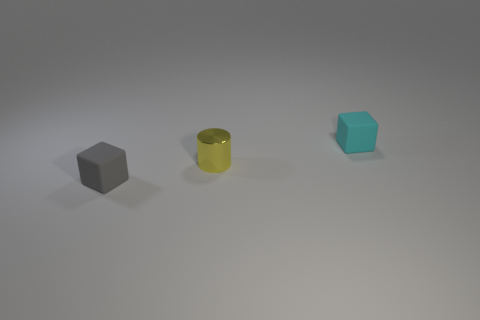There is a matte thing that is in front of the matte object behind the rubber thing in front of the tiny metal cylinder; what size is it?
Offer a very short reply. Small. There is a gray thing; is its shape the same as the yellow shiny object that is in front of the cyan block?
Ensure brevity in your answer.  No. How many things are left of the small cyan cube and behind the metal cylinder?
Keep it short and to the point. 0. How many purple things are either matte cubes or large metallic blocks?
Give a very brief answer. 0. There is a tiny rubber object that is behind the gray cube; is it the same color as the tiny cylinder behind the small gray matte thing?
Your response must be concise. No. What color is the rubber cube that is to the left of the matte block that is on the right side of the rubber cube that is in front of the tiny cyan rubber block?
Make the answer very short. Gray. There is a block that is in front of the tiny cyan matte thing; is there a gray rubber block that is right of it?
Your answer should be compact. No. There is a matte thing that is behind the small yellow metallic cylinder; is its shape the same as the small gray object?
Give a very brief answer. Yes. Are there any other things that have the same shape as the small gray matte object?
Ensure brevity in your answer.  Yes. How many cubes are cyan things or tiny gray matte things?
Your answer should be compact. 2. 